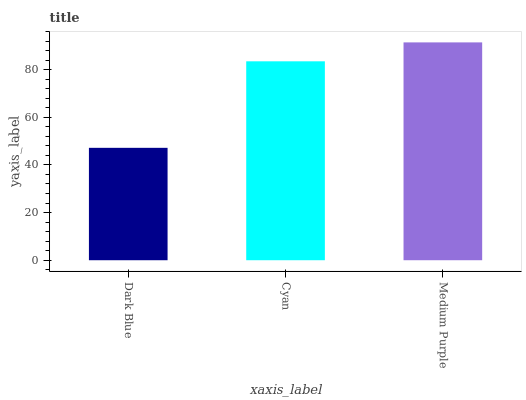Is Dark Blue the minimum?
Answer yes or no. Yes. Is Medium Purple the maximum?
Answer yes or no. Yes. Is Cyan the minimum?
Answer yes or no. No. Is Cyan the maximum?
Answer yes or no. No. Is Cyan greater than Dark Blue?
Answer yes or no. Yes. Is Dark Blue less than Cyan?
Answer yes or no. Yes. Is Dark Blue greater than Cyan?
Answer yes or no. No. Is Cyan less than Dark Blue?
Answer yes or no. No. Is Cyan the high median?
Answer yes or no. Yes. Is Cyan the low median?
Answer yes or no. Yes. Is Medium Purple the high median?
Answer yes or no. No. Is Dark Blue the low median?
Answer yes or no. No. 